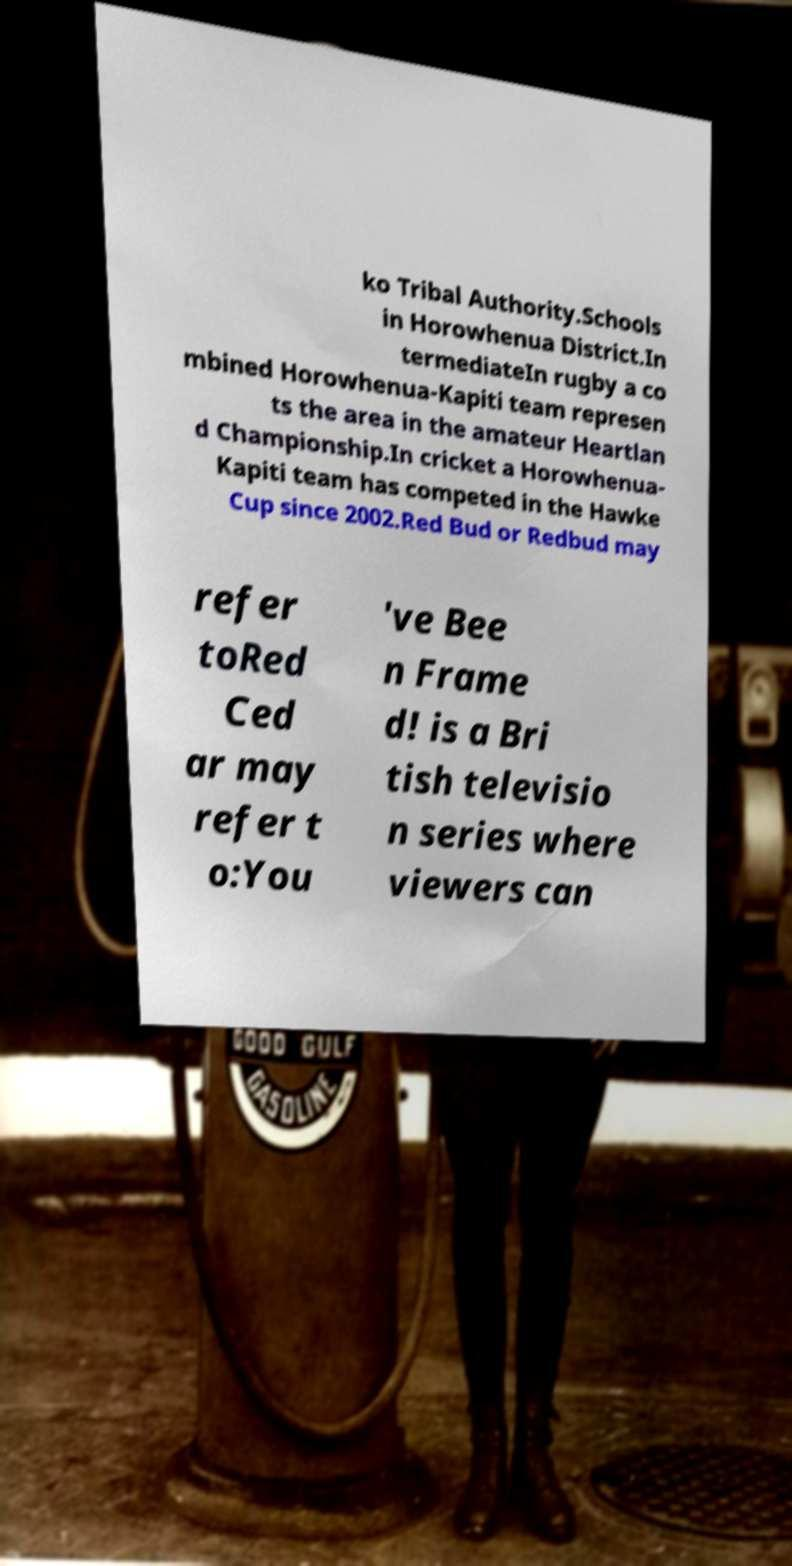What messages or text are displayed in this image? I need them in a readable, typed format. ko Tribal Authority.Schools in Horowhenua District.In termediateIn rugby a co mbined Horowhenua-Kapiti team represen ts the area in the amateur Heartlan d Championship.In cricket a Horowhenua- Kapiti team has competed in the Hawke Cup since 2002.Red Bud or Redbud may refer toRed Ced ar may refer t o:You 've Bee n Frame d! is a Bri tish televisio n series where viewers can 